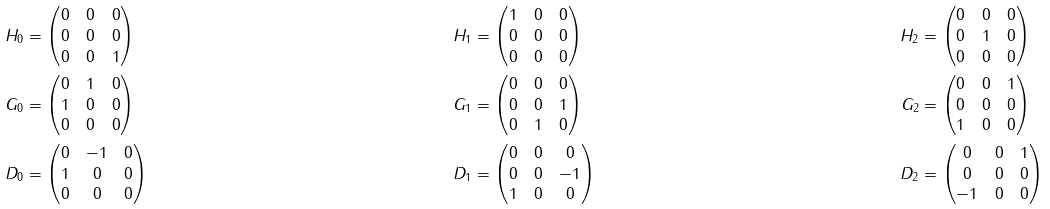Convert formula to latex. <formula><loc_0><loc_0><loc_500><loc_500>H _ { 0 } & = \begin{pmatrix} 0 & 0 & 0 \\ 0 & 0 & 0 \\ 0 & 0 & 1 \end{pmatrix} & H _ { 1 } & = \begin{pmatrix} 1 & 0 & 0 \\ 0 & 0 & 0 \\ 0 & 0 & 0 \end{pmatrix} & H _ { 2 } & = \begin{pmatrix} 0 & 0 & 0 \\ 0 & 1 & 0 \\ 0 & 0 & 0 \end{pmatrix} \\ G _ { 0 } & = \begin{pmatrix} 0 & 1 & 0 \\ 1 & 0 & 0 \\ 0 & 0 & 0 \end{pmatrix} & G _ { 1 } & = \begin{pmatrix} 0 & 0 & 0 \\ 0 & 0 & 1 \\ 0 & 1 & 0 \end{pmatrix} & G _ { 2 } & = \begin{pmatrix} 0 & 0 & 1 \\ 0 & 0 & 0 \\ 1 & 0 & 0 \end{pmatrix} \\ D _ { 0 } & = \begin{pmatrix} 0 & - 1 & 0 \\ 1 & 0 & 0 \\ 0 & 0 & 0 \end{pmatrix} & D _ { 1 } & = \begin{pmatrix} 0 & 0 & 0 \\ 0 & 0 & - 1 \\ 1 & 0 & 0 \end{pmatrix} & D _ { 2 } & = \begin{pmatrix} 0 & 0 & 1 \\ 0 & 0 & 0 \\ - 1 & 0 & 0 \end{pmatrix}</formula> 